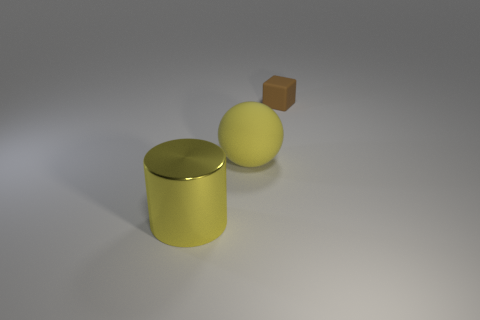What is the color of the metallic thing that is the same size as the yellow ball?
Your answer should be very brief. Yellow. What number of big rubber things are the same shape as the yellow metal object?
Ensure brevity in your answer.  0. What color is the rubber object that is in front of the block?
Give a very brief answer. Yellow. What number of shiny things are either large spheres or small brown objects?
Offer a very short reply. 0. There is a large metallic thing that is the same color as the large ball; what shape is it?
Provide a short and direct response. Cylinder. How many yellow rubber spheres are the same size as the brown thing?
Offer a terse response. 0. There is a thing that is behind the yellow metallic cylinder and on the left side of the brown object; what is its color?
Your response must be concise. Yellow. What number of objects are either large shiny cylinders or small things?
Give a very brief answer. 2. What number of small things are either yellow rubber balls or yellow shiny cylinders?
Keep it short and to the point. 0. Is there any other thing that is the same color as the big cylinder?
Offer a terse response. Yes. 